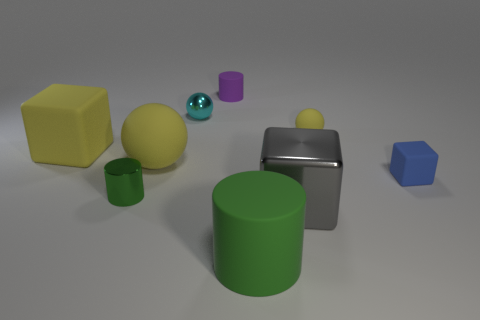Is the shape of the purple object the same as the big green rubber object?
Make the answer very short. Yes. What size is the cube that is the same color as the large ball?
Keep it short and to the point. Large. Are there an equal number of yellow balls that are behind the cyan ball and small yellow metallic cylinders?
Give a very brief answer. Yes. How many small things are right of the cyan sphere and in front of the tiny cyan shiny sphere?
Make the answer very short. 2. What size is the purple thing that is the same material as the small cube?
Your answer should be compact. Small. How many purple objects have the same shape as the large green rubber thing?
Offer a terse response. 1. Are there more large cubes on the left side of the small green cylinder than big red matte balls?
Offer a very short reply. Yes. There is a rubber object that is in front of the big rubber cube and right of the big green thing; what shape is it?
Your response must be concise. Cube. Is the purple rubber object the same size as the shiny sphere?
Make the answer very short. Yes. There is a tiny green cylinder; how many small things are behind it?
Offer a very short reply. 4. 